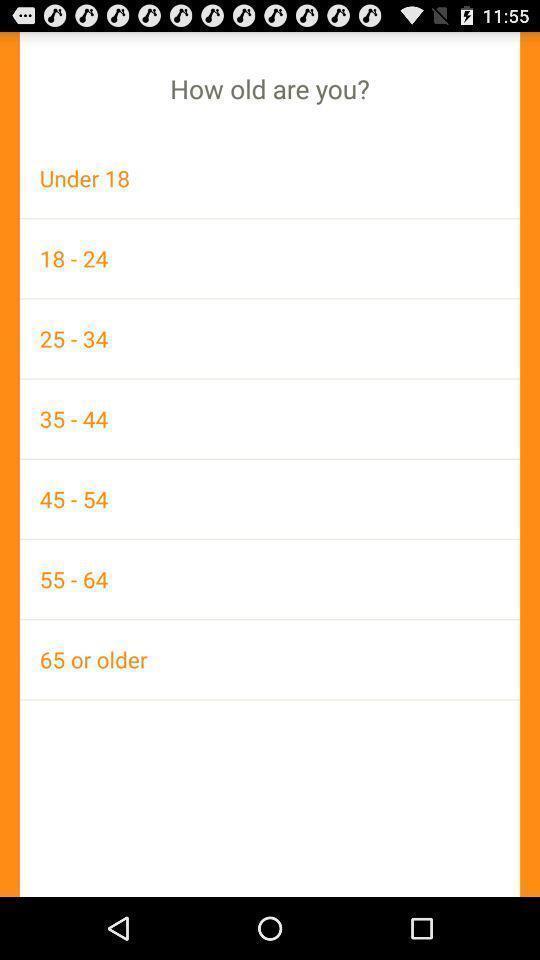Provide a description of this screenshot. Screen displaying to select the age. 